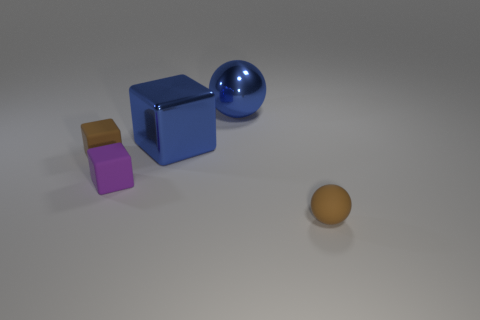Subtract all blue spheres. How many spheres are left? 1 Subtract all small brown rubber cubes. How many cubes are left? 2 Subtract all green cylinders. How many yellow spheres are left? 0 Add 5 tiny balls. How many tiny balls exist? 6 Add 2 tiny objects. How many objects exist? 7 Subtract 0 red balls. How many objects are left? 5 Subtract all balls. How many objects are left? 3 Subtract 1 spheres. How many spheres are left? 1 Subtract all red cubes. Subtract all green cylinders. How many cubes are left? 3 Subtract all large yellow metallic objects. Subtract all blue things. How many objects are left? 3 